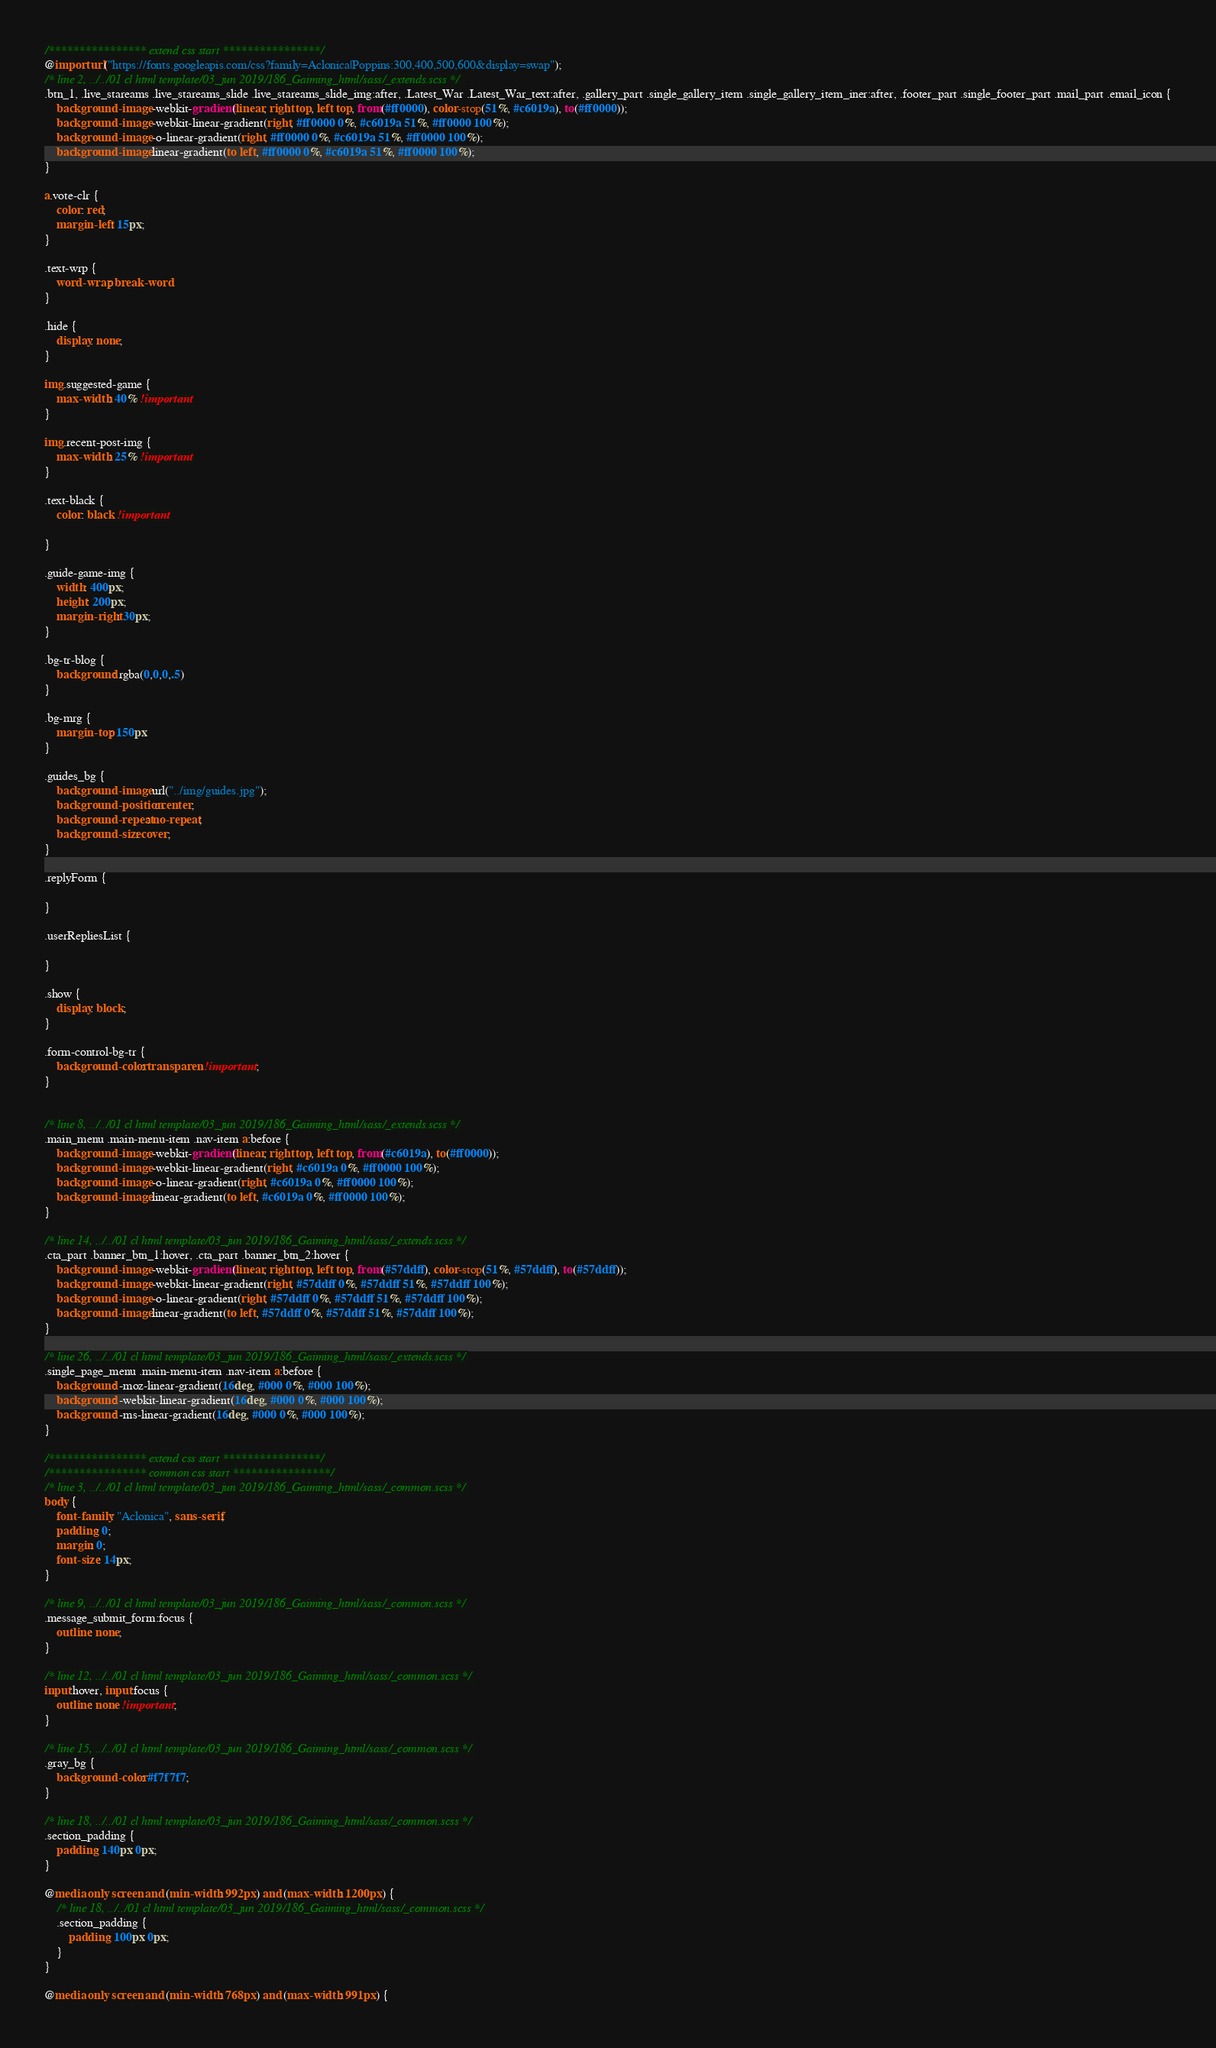<code> <loc_0><loc_0><loc_500><loc_500><_CSS_>/**************** extend css start ****************/
@import url("https://fonts.googleapis.com/css?family=Aclonica|Poppins:300,400,500,600&display=swap");
/* line 2, ../../01 cl html template/03_jun 2019/186_Gaiming_html/sass/_extends.scss */
.btn_1, .live_stareams .live_stareams_slide .live_stareams_slide_img:after, .Latest_War .Latest_War_text:after, .gallery_part .single_gallery_item .single_gallery_item_iner:after, .footer_part .single_footer_part .mail_part .email_icon {
    background-image: -webkit-gradient(linear, right top, left top, from(#ff0000), color-stop(51%, #c6019a), to(#ff0000));
    background-image: -webkit-linear-gradient(right, #ff0000 0%, #c6019a 51%, #ff0000 100%);
    background-image: -o-linear-gradient(right, #ff0000 0%, #c6019a 51%, #ff0000 100%);
    background-image: linear-gradient(to left, #ff0000 0%, #c6019a 51%, #ff0000 100%);
}

a.vote-clr {
    color: red;
    margin-left: 15px;
}

.text-wrp {
    word-wrap: break-word
}

.hide {
    display: none;
}

img.suggested-game {
    max-width: 40% !important
}

img.recent-post-img {
    max-width: 25% !important
}

.text-black {
    color: black !important

}

.guide-game-img {
    width: 400px;
    height: 200px;
    margin-right: 30px;
}

.bg-tr-blog {
    background: rgba(0,0,0,.5)
}

.bg-mrg {
    margin-top: 150px
}

.guides_bg {
    background-image: url("../img/guides.jpg");
    background-position: center;
    background-repeat: no-repeat;
    background-size: cover;
}

.replyForm {

}

.userRepliesList {

}

.show {
    display: block;
}

.form-control-bg-tr {
    background-color: transparent !important;
}


/* line 8, ../../01 cl html template/03_jun 2019/186_Gaiming_html/sass/_extends.scss */
.main_menu .main-menu-item .nav-item a:before {
    background-image: -webkit-gradient(linear, right top, left top, from(#c6019a), to(#ff0000));
    background-image: -webkit-linear-gradient(right, #c6019a 0%, #ff0000 100%);
    background-image: -o-linear-gradient(right, #c6019a 0%, #ff0000 100%);
    background-image: linear-gradient(to left, #c6019a 0%, #ff0000 100%);
}

/* line 14, ../../01 cl html template/03_jun 2019/186_Gaiming_html/sass/_extends.scss */
.cta_part .banner_btn_1:hover, .cta_part .banner_btn_2:hover {
    background-image: -webkit-gradient(linear, right top, left top, from(#57ddff), color-stop(51%, #57ddff), to(#57ddff));
    background-image: -webkit-linear-gradient(right, #57ddff 0%, #57ddff 51%, #57ddff 100%);
    background-image: -o-linear-gradient(right, #57ddff 0%, #57ddff 51%, #57ddff 100%);
    background-image: linear-gradient(to left, #57ddff 0%, #57ddff 51%, #57ddff 100%);
}

/* line 26, ../../01 cl html template/03_jun 2019/186_Gaiming_html/sass/_extends.scss */
.single_page_menu .main-menu-item .nav-item a:before {
    background: -moz-linear-gradient(16deg, #000 0%, #000 100%);
    background: -webkit-linear-gradient(16deg, #000 0%, #000 100%);
    background: -ms-linear-gradient(16deg, #000 0%, #000 100%);
}

/**************** extend css start ****************/
/**************** common css start ****************/
/* line 3, ../../01 cl html template/03_jun 2019/186_Gaiming_html/sass/_common.scss */
body {
    font-family: "Aclonica", sans-serif;
    padding: 0;
    margin: 0;
    font-size: 14px;
}

/* line 9, ../../01 cl html template/03_jun 2019/186_Gaiming_html/sass/_common.scss */
.message_submit_form:focus {
    outline: none;
}

/* line 12, ../../01 cl html template/03_jun 2019/186_Gaiming_html/sass/_common.scss */
input:hover, input:focus {
    outline: none !important;
}

/* line 15, ../../01 cl html template/03_jun 2019/186_Gaiming_html/sass/_common.scss */
.gray_bg {
    background-color: #f7f7f7;
}

/* line 18, ../../01 cl html template/03_jun 2019/186_Gaiming_html/sass/_common.scss */
.section_padding {
    padding: 140px 0px;
}

@media only screen and (min-width: 992px) and (max-width: 1200px) {
    /* line 18, ../../01 cl html template/03_jun 2019/186_Gaiming_html/sass/_common.scss */
    .section_padding {
        padding: 100px 0px;
    }
}

@media only screen and (min-width: 768px) and (max-width: 991px) {</code> 